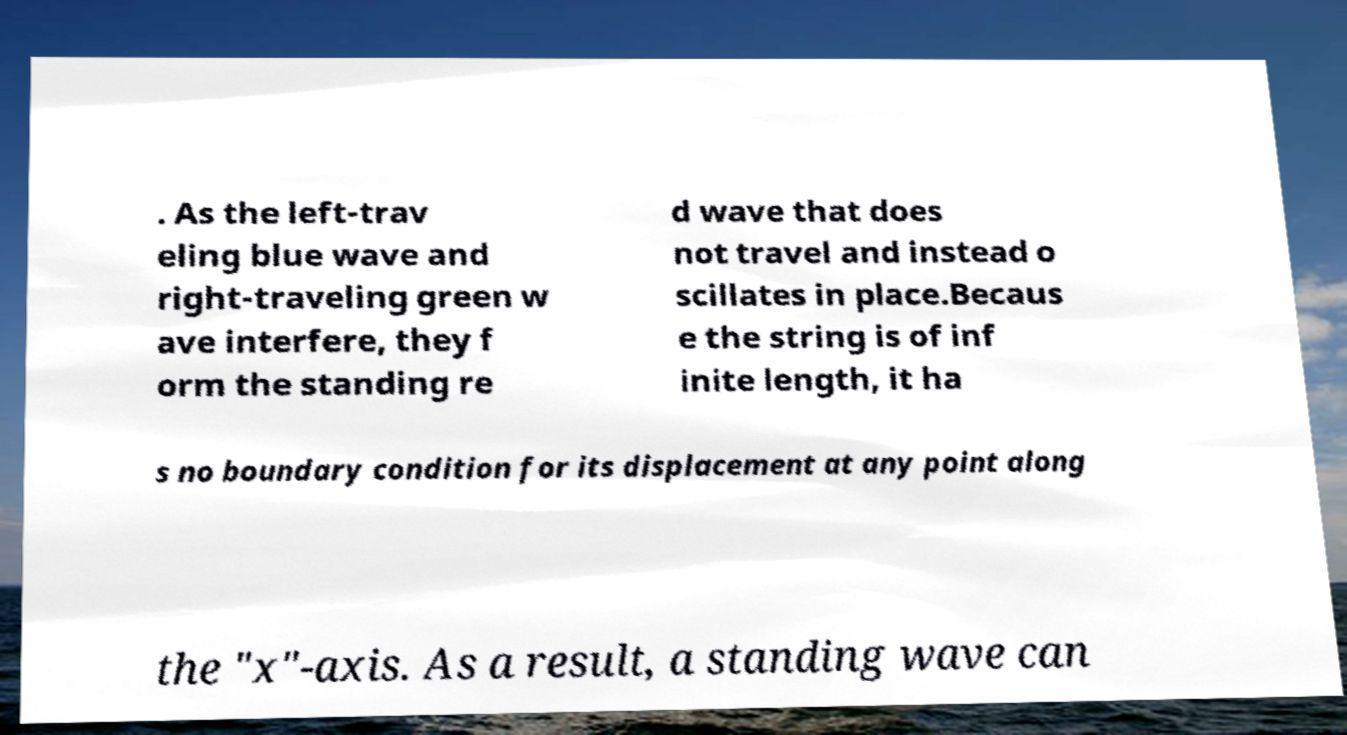For documentation purposes, I need the text within this image transcribed. Could you provide that? . As the left-trav eling blue wave and right-traveling green w ave interfere, they f orm the standing re d wave that does not travel and instead o scillates in place.Becaus e the string is of inf inite length, it ha s no boundary condition for its displacement at any point along the "x"-axis. As a result, a standing wave can 